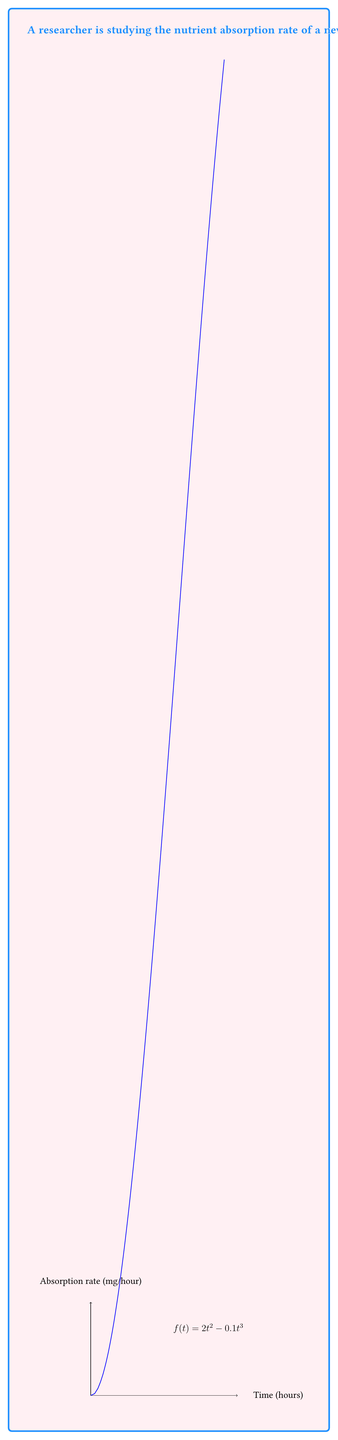Teach me how to tackle this problem. To find the total amount of nutrients absorbed, we need to calculate the area under the curve of the absorption rate function from $t=0$ to $t=10$. This can be done using definite integration:

1) Set up the definite integral:
   $$\int_0^{10} (2t^2 - 0.1t^3) dt$$

2) Integrate the function:
   $$\left[\frac{2t^3}{3} - \frac{0.1t^4}{4}\right]_0^{10}$$

3) Evaluate the integral at the upper and lower bounds:
   $$\left(\frac{2(10^3)}{3} - \frac{0.1(10^4)}{4}\right) - \left(\frac{2(0^3)}{3} - \frac{0.1(0^4)}{4}\right)$$

4) Simplify:
   $$\left(\frac{2000}{3} - 250\right) - 0$$
   $$\frac{2000}{3} - 250$$
   $$666.67 - 250 = 416.67$$

Therefore, the total amount of nutrients absorbed during the first 10 hours is approximately 416.67 mg.
Answer: 416.67 mg 